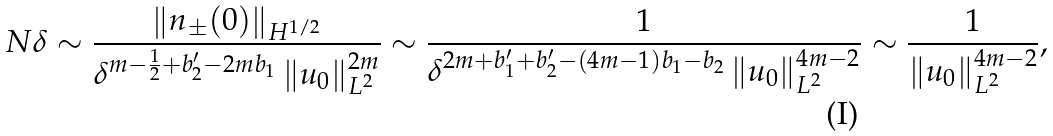Convert formula to latex. <formula><loc_0><loc_0><loc_500><loc_500>N \delta \sim \frac { \left \| n _ { \pm } ( 0 ) \right \| _ { H ^ { 1 / 2 } } } { \delta ^ { m - \frac { 1 } { 2 } + b ^ { \prime } _ { 2 } - 2 m b _ { 1 } } \left \| u _ { 0 } \right \| ^ { 2 m } _ { L ^ { 2 } } } \sim \frac { 1 } { \delta ^ { 2 m + b ^ { \prime } _ { 1 } + b ^ { \prime } _ { 2 } - ( 4 m - 1 ) b _ { 1 } - b _ { 2 } } \left \| u _ { 0 } \right \| ^ { 4 m - 2 } _ { L ^ { 2 } } } \sim \frac { 1 } { \left \| u _ { 0 } \right \| ^ { 4 m - 2 } _ { L ^ { 2 } } } ,</formula> 